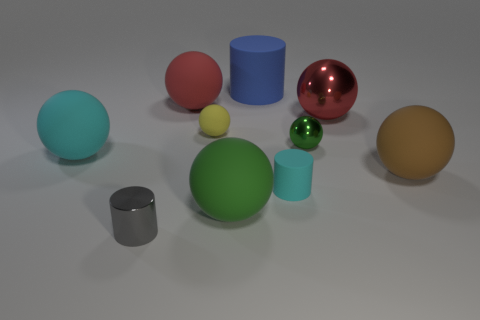What is the size of the rubber thing that is the same color as the tiny metal sphere? The rubber object matching the color of the tiny metal sphere appears to be a large green ball, which is notably bigger in size than the small sphere. 